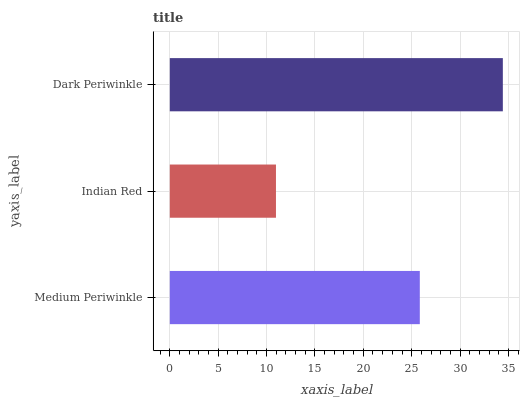Is Indian Red the minimum?
Answer yes or no. Yes. Is Dark Periwinkle the maximum?
Answer yes or no. Yes. Is Dark Periwinkle the minimum?
Answer yes or no. No. Is Indian Red the maximum?
Answer yes or no. No. Is Dark Periwinkle greater than Indian Red?
Answer yes or no. Yes. Is Indian Red less than Dark Periwinkle?
Answer yes or no. Yes. Is Indian Red greater than Dark Periwinkle?
Answer yes or no. No. Is Dark Periwinkle less than Indian Red?
Answer yes or no. No. Is Medium Periwinkle the high median?
Answer yes or no. Yes. Is Medium Periwinkle the low median?
Answer yes or no. Yes. Is Dark Periwinkle the high median?
Answer yes or no. No. Is Dark Periwinkle the low median?
Answer yes or no. No. 